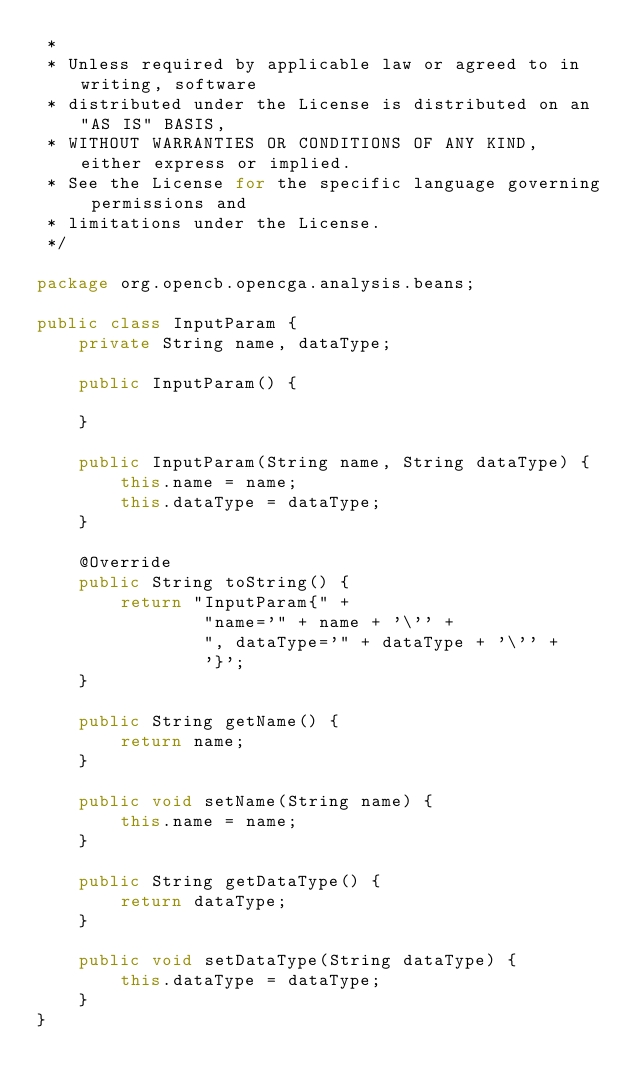<code> <loc_0><loc_0><loc_500><loc_500><_Java_> *
 * Unless required by applicable law or agreed to in writing, software
 * distributed under the License is distributed on an "AS IS" BASIS,
 * WITHOUT WARRANTIES OR CONDITIONS OF ANY KIND, either express or implied.
 * See the License for the specific language governing permissions and
 * limitations under the License.
 */

package org.opencb.opencga.analysis.beans;

public class InputParam {
    private String name, dataType;

    public InputParam() {

    }

    public InputParam(String name, String dataType) {
        this.name = name;
        this.dataType = dataType;
    }

    @Override
    public String toString() {
        return "InputParam{" +
                "name='" + name + '\'' +
                ", dataType='" + dataType + '\'' +
                '}';
    }

    public String getName() {
        return name;
    }

    public void setName(String name) {
        this.name = name;
    }

    public String getDataType() {
        return dataType;
    }

    public void setDataType(String dataType) {
        this.dataType = dataType;
    }
}
</code> 